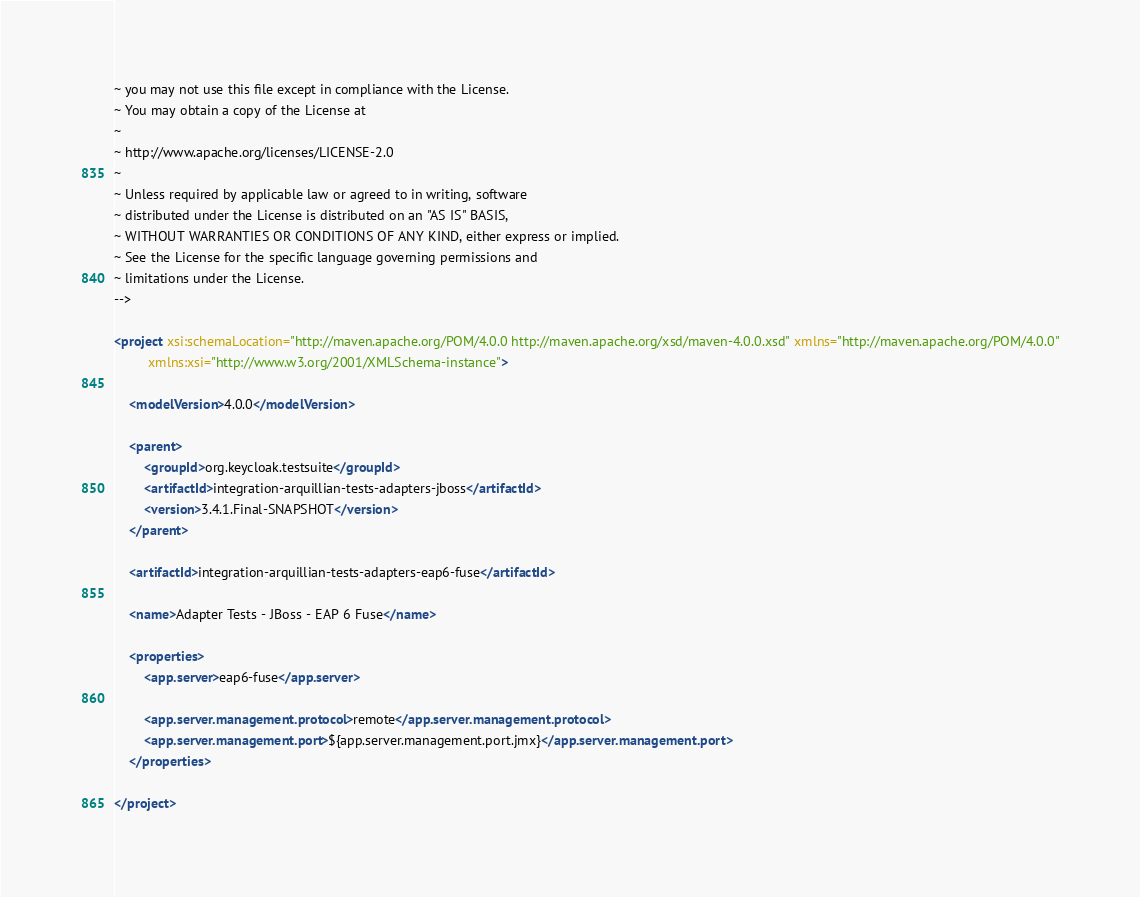<code> <loc_0><loc_0><loc_500><loc_500><_XML_>~ you may not use this file except in compliance with the License.
~ You may obtain a copy of the License at
~
~ http://www.apache.org/licenses/LICENSE-2.0
~
~ Unless required by applicable law or agreed to in writing, software
~ distributed under the License is distributed on an "AS IS" BASIS,
~ WITHOUT WARRANTIES OR CONDITIONS OF ANY KIND, either express or implied.
~ See the License for the specific language governing permissions and
~ limitations under the License.
-->

<project xsi:schemaLocation="http://maven.apache.org/POM/4.0.0 http://maven.apache.org/xsd/maven-4.0.0.xsd" xmlns="http://maven.apache.org/POM/4.0.0"
         xmlns:xsi="http://www.w3.org/2001/XMLSchema-instance">

    <modelVersion>4.0.0</modelVersion>

    <parent>
        <groupId>org.keycloak.testsuite</groupId>
        <artifactId>integration-arquillian-tests-adapters-jboss</artifactId>
        <version>3.4.1.Final-SNAPSHOT</version>
    </parent>

    <artifactId>integration-arquillian-tests-adapters-eap6-fuse</artifactId>

    <name>Adapter Tests - JBoss - EAP 6 Fuse</name>
    
    <properties>
        <app.server>eap6-fuse</app.server>

        <app.server.management.protocol>remote</app.server.management.protocol>
        <app.server.management.port>${app.server.management.port.jmx}</app.server.management.port>
    </properties>
    
</project></code> 